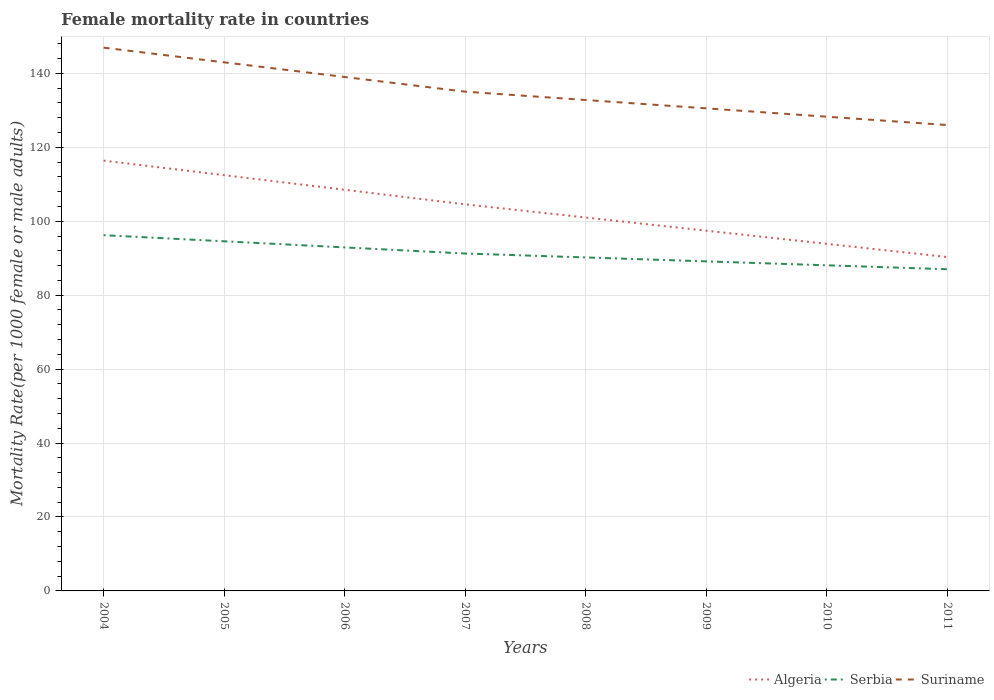Is the number of lines equal to the number of legend labels?
Provide a succinct answer. Yes. Across all years, what is the maximum female mortality rate in Algeria?
Provide a succinct answer. 90.32. In which year was the female mortality rate in Algeria maximum?
Ensure brevity in your answer.  2011. What is the total female mortality rate in Suriname in the graph?
Provide a short and direct response. 12.99. What is the difference between the highest and the second highest female mortality rate in Suriname?
Offer a terse response. 20.93. What is the difference between the highest and the lowest female mortality rate in Suriname?
Your answer should be compact. 3. Is the female mortality rate in Serbia strictly greater than the female mortality rate in Suriname over the years?
Keep it short and to the point. Yes. How many lines are there?
Your answer should be compact. 3. How many years are there in the graph?
Your answer should be compact. 8. What is the difference between two consecutive major ticks on the Y-axis?
Your answer should be compact. 20. Does the graph contain any zero values?
Ensure brevity in your answer.  No. Where does the legend appear in the graph?
Offer a terse response. Bottom right. How many legend labels are there?
Your answer should be very brief. 3. How are the legend labels stacked?
Offer a very short reply. Horizontal. What is the title of the graph?
Ensure brevity in your answer.  Female mortality rate in countries. What is the label or title of the Y-axis?
Your answer should be very brief. Mortality Rate(per 1000 female or male adults). What is the Mortality Rate(per 1000 female or male adults) in Algeria in 2004?
Give a very brief answer. 116.4. What is the Mortality Rate(per 1000 female or male adults) of Serbia in 2004?
Offer a terse response. 96.22. What is the Mortality Rate(per 1000 female or male adults) of Suriname in 2004?
Your response must be concise. 146.95. What is the Mortality Rate(per 1000 female or male adults) in Algeria in 2005?
Give a very brief answer. 112.46. What is the Mortality Rate(per 1000 female or male adults) in Serbia in 2005?
Make the answer very short. 94.57. What is the Mortality Rate(per 1000 female or male adults) of Suriname in 2005?
Your answer should be compact. 142.98. What is the Mortality Rate(per 1000 female or male adults) of Algeria in 2006?
Your response must be concise. 108.51. What is the Mortality Rate(per 1000 female or male adults) in Serbia in 2006?
Your answer should be compact. 92.92. What is the Mortality Rate(per 1000 female or male adults) in Suriname in 2006?
Offer a terse response. 139.02. What is the Mortality Rate(per 1000 female or male adults) of Algeria in 2007?
Your answer should be very brief. 104.57. What is the Mortality Rate(per 1000 female or male adults) in Serbia in 2007?
Your answer should be compact. 91.27. What is the Mortality Rate(per 1000 female or male adults) in Suriname in 2007?
Make the answer very short. 135.05. What is the Mortality Rate(per 1000 female or male adults) in Algeria in 2008?
Your answer should be compact. 101.01. What is the Mortality Rate(per 1000 female or male adults) of Serbia in 2008?
Your response must be concise. 90.21. What is the Mortality Rate(per 1000 female or male adults) of Suriname in 2008?
Make the answer very short. 132.79. What is the Mortality Rate(per 1000 female or male adults) of Algeria in 2009?
Offer a terse response. 97.44. What is the Mortality Rate(per 1000 female or male adults) in Serbia in 2009?
Give a very brief answer. 89.14. What is the Mortality Rate(per 1000 female or male adults) of Suriname in 2009?
Your answer should be very brief. 130.53. What is the Mortality Rate(per 1000 female or male adults) of Algeria in 2010?
Make the answer very short. 93.88. What is the Mortality Rate(per 1000 female or male adults) of Serbia in 2010?
Your answer should be very brief. 88.08. What is the Mortality Rate(per 1000 female or male adults) in Suriname in 2010?
Your response must be concise. 128.28. What is the Mortality Rate(per 1000 female or male adults) in Algeria in 2011?
Give a very brief answer. 90.32. What is the Mortality Rate(per 1000 female or male adults) in Serbia in 2011?
Offer a very short reply. 87.02. What is the Mortality Rate(per 1000 female or male adults) of Suriname in 2011?
Give a very brief answer. 126.02. Across all years, what is the maximum Mortality Rate(per 1000 female or male adults) in Algeria?
Keep it short and to the point. 116.4. Across all years, what is the maximum Mortality Rate(per 1000 female or male adults) of Serbia?
Provide a succinct answer. 96.22. Across all years, what is the maximum Mortality Rate(per 1000 female or male adults) of Suriname?
Give a very brief answer. 146.95. Across all years, what is the minimum Mortality Rate(per 1000 female or male adults) in Algeria?
Your answer should be very brief. 90.32. Across all years, what is the minimum Mortality Rate(per 1000 female or male adults) in Serbia?
Your answer should be very brief. 87.02. Across all years, what is the minimum Mortality Rate(per 1000 female or male adults) in Suriname?
Keep it short and to the point. 126.02. What is the total Mortality Rate(per 1000 female or male adults) in Algeria in the graph?
Make the answer very short. 824.58. What is the total Mortality Rate(per 1000 female or male adults) in Serbia in the graph?
Keep it short and to the point. 729.43. What is the total Mortality Rate(per 1000 female or male adults) in Suriname in the graph?
Your answer should be very brief. 1081.62. What is the difference between the Mortality Rate(per 1000 female or male adults) of Algeria in 2004 and that in 2005?
Your answer should be compact. 3.94. What is the difference between the Mortality Rate(per 1000 female or male adults) of Serbia in 2004 and that in 2005?
Ensure brevity in your answer.  1.65. What is the difference between the Mortality Rate(per 1000 female or male adults) of Suriname in 2004 and that in 2005?
Provide a succinct answer. 3.97. What is the difference between the Mortality Rate(per 1000 female or male adults) of Algeria in 2004 and that in 2006?
Your response must be concise. 7.89. What is the difference between the Mortality Rate(per 1000 female or male adults) in Serbia in 2004 and that in 2006?
Your response must be concise. 3.3. What is the difference between the Mortality Rate(per 1000 female or male adults) of Suriname in 2004 and that in 2006?
Ensure brevity in your answer.  7.94. What is the difference between the Mortality Rate(per 1000 female or male adults) of Algeria in 2004 and that in 2007?
Your answer should be compact. 11.83. What is the difference between the Mortality Rate(per 1000 female or male adults) in Serbia in 2004 and that in 2007?
Your answer should be compact. 4.96. What is the difference between the Mortality Rate(per 1000 female or male adults) of Suriname in 2004 and that in 2007?
Offer a terse response. 11.9. What is the difference between the Mortality Rate(per 1000 female or male adults) of Algeria in 2004 and that in 2008?
Your response must be concise. 15.39. What is the difference between the Mortality Rate(per 1000 female or male adults) in Serbia in 2004 and that in 2008?
Make the answer very short. 6.02. What is the difference between the Mortality Rate(per 1000 female or male adults) of Suriname in 2004 and that in 2008?
Keep it short and to the point. 14.16. What is the difference between the Mortality Rate(per 1000 female or male adults) of Algeria in 2004 and that in 2009?
Provide a succinct answer. 18.96. What is the difference between the Mortality Rate(per 1000 female or male adults) in Serbia in 2004 and that in 2009?
Ensure brevity in your answer.  7.08. What is the difference between the Mortality Rate(per 1000 female or male adults) of Suriname in 2004 and that in 2009?
Keep it short and to the point. 16.42. What is the difference between the Mortality Rate(per 1000 female or male adults) in Algeria in 2004 and that in 2010?
Offer a very short reply. 22.52. What is the difference between the Mortality Rate(per 1000 female or male adults) in Serbia in 2004 and that in 2010?
Your answer should be compact. 8.14. What is the difference between the Mortality Rate(per 1000 female or male adults) of Suriname in 2004 and that in 2010?
Provide a succinct answer. 18.68. What is the difference between the Mortality Rate(per 1000 female or male adults) in Algeria in 2004 and that in 2011?
Your response must be concise. 26.08. What is the difference between the Mortality Rate(per 1000 female or male adults) of Serbia in 2004 and that in 2011?
Ensure brevity in your answer.  9.21. What is the difference between the Mortality Rate(per 1000 female or male adults) in Suriname in 2004 and that in 2011?
Provide a succinct answer. 20.93. What is the difference between the Mortality Rate(per 1000 female or male adults) of Algeria in 2005 and that in 2006?
Ensure brevity in your answer.  3.94. What is the difference between the Mortality Rate(per 1000 female or male adults) in Serbia in 2005 and that in 2006?
Give a very brief answer. 1.65. What is the difference between the Mortality Rate(per 1000 female or male adults) in Suriname in 2005 and that in 2006?
Make the answer very short. 3.97. What is the difference between the Mortality Rate(per 1000 female or male adults) of Algeria in 2005 and that in 2007?
Keep it short and to the point. 7.89. What is the difference between the Mortality Rate(per 1000 female or male adults) of Serbia in 2005 and that in 2007?
Offer a terse response. 3.3. What is the difference between the Mortality Rate(per 1000 female or male adults) of Suriname in 2005 and that in 2007?
Keep it short and to the point. 7.94. What is the difference between the Mortality Rate(per 1000 female or male adults) in Algeria in 2005 and that in 2008?
Give a very brief answer. 11.45. What is the difference between the Mortality Rate(per 1000 female or male adults) in Serbia in 2005 and that in 2008?
Ensure brevity in your answer.  4.37. What is the difference between the Mortality Rate(per 1000 female or male adults) of Suriname in 2005 and that in 2008?
Your answer should be compact. 10.19. What is the difference between the Mortality Rate(per 1000 female or male adults) in Algeria in 2005 and that in 2009?
Keep it short and to the point. 15.01. What is the difference between the Mortality Rate(per 1000 female or male adults) of Serbia in 2005 and that in 2009?
Give a very brief answer. 5.43. What is the difference between the Mortality Rate(per 1000 female or male adults) in Suriname in 2005 and that in 2009?
Your response must be concise. 12.45. What is the difference between the Mortality Rate(per 1000 female or male adults) in Algeria in 2005 and that in 2010?
Your answer should be very brief. 18.58. What is the difference between the Mortality Rate(per 1000 female or male adults) of Serbia in 2005 and that in 2010?
Make the answer very short. 6.49. What is the difference between the Mortality Rate(per 1000 female or male adults) of Suriname in 2005 and that in 2010?
Make the answer very short. 14.71. What is the difference between the Mortality Rate(per 1000 female or male adults) in Algeria in 2005 and that in 2011?
Keep it short and to the point. 22.14. What is the difference between the Mortality Rate(per 1000 female or male adults) of Serbia in 2005 and that in 2011?
Make the answer very short. 7.56. What is the difference between the Mortality Rate(per 1000 female or male adults) of Suriname in 2005 and that in 2011?
Make the answer very short. 16.96. What is the difference between the Mortality Rate(per 1000 female or male adults) of Algeria in 2006 and that in 2007?
Your answer should be very brief. 3.94. What is the difference between the Mortality Rate(per 1000 female or male adults) in Serbia in 2006 and that in 2007?
Give a very brief answer. 1.65. What is the difference between the Mortality Rate(per 1000 female or male adults) in Suriname in 2006 and that in 2007?
Give a very brief answer. 3.97. What is the difference between the Mortality Rate(per 1000 female or male adults) in Algeria in 2006 and that in 2008?
Make the answer very short. 7.51. What is the difference between the Mortality Rate(per 1000 female or male adults) in Serbia in 2006 and that in 2008?
Offer a very short reply. 2.71. What is the difference between the Mortality Rate(per 1000 female or male adults) in Suriname in 2006 and that in 2008?
Provide a succinct answer. 6.22. What is the difference between the Mortality Rate(per 1000 female or male adults) of Algeria in 2006 and that in 2009?
Make the answer very short. 11.07. What is the difference between the Mortality Rate(per 1000 female or male adults) of Serbia in 2006 and that in 2009?
Provide a short and direct response. 3.78. What is the difference between the Mortality Rate(per 1000 female or male adults) in Suriname in 2006 and that in 2009?
Provide a short and direct response. 8.48. What is the difference between the Mortality Rate(per 1000 female or male adults) of Algeria in 2006 and that in 2010?
Offer a terse response. 14.63. What is the difference between the Mortality Rate(per 1000 female or male adults) in Serbia in 2006 and that in 2010?
Offer a very short reply. 4.84. What is the difference between the Mortality Rate(per 1000 female or male adults) of Suriname in 2006 and that in 2010?
Your answer should be compact. 10.74. What is the difference between the Mortality Rate(per 1000 female or male adults) of Algeria in 2006 and that in 2011?
Provide a short and direct response. 18.2. What is the difference between the Mortality Rate(per 1000 female or male adults) of Serbia in 2006 and that in 2011?
Keep it short and to the point. 5.9. What is the difference between the Mortality Rate(per 1000 female or male adults) in Suriname in 2006 and that in 2011?
Your answer should be very brief. 12.99. What is the difference between the Mortality Rate(per 1000 female or male adults) in Algeria in 2007 and that in 2008?
Keep it short and to the point. 3.56. What is the difference between the Mortality Rate(per 1000 female or male adults) of Serbia in 2007 and that in 2008?
Your answer should be compact. 1.06. What is the difference between the Mortality Rate(per 1000 female or male adults) in Suriname in 2007 and that in 2008?
Ensure brevity in your answer.  2.26. What is the difference between the Mortality Rate(per 1000 female or male adults) of Algeria in 2007 and that in 2009?
Keep it short and to the point. 7.13. What is the difference between the Mortality Rate(per 1000 female or male adults) in Serbia in 2007 and that in 2009?
Your answer should be very brief. 2.13. What is the difference between the Mortality Rate(per 1000 female or male adults) of Suriname in 2007 and that in 2009?
Offer a terse response. 4.51. What is the difference between the Mortality Rate(per 1000 female or male adults) in Algeria in 2007 and that in 2010?
Keep it short and to the point. 10.69. What is the difference between the Mortality Rate(per 1000 female or male adults) in Serbia in 2007 and that in 2010?
Make the answer very short. 3.19. What is the difference between the Mortality Rate(per 1000 female or male adults) in Suriname in 2007 and that in 2010?
Make the answer very short. 6.77. What is the difference between the Mortality Rate(per 1000 female or male adults) of Algeria in 2007 and that in 2011?
Ensure brevity in your answer.  14.25. What is the difference between the Mortality Rate(per 1000 female or male adults) in Serbia in 2007 and that in 2011?
Make the answer very short. 4.25. What is the difference between the Mortality Rate(per 1000 female or male adults) in Suriname in 2007 and that in 2011?
Offer a very short reply. 9.03. What is the difference between the Mortality Rate(per 1000 female or male adults) of Algeria in 2008 and that in 2009?
Your answer should be very brief. 3.56. What is the difference between the Mortality Rate(per 1000 female or male adults) in Serbia in 2008 and that in 2009?
Ensure brevity in your answer.  1.06. What is the difference between the Mortality Rate(per 1000 female or male adults) in Suriname in 2008 and that in 2009?
Your response must be concise. 2.26. What is the difference between the Mortality Rate(per 1000 female or male adults) in Algeria in 2008 and that in 2010?
Your answer should be very brief. 7.13. What is the difference between the Mortality Rate(per 1000 female or male adults) of Serbia in 2008 and that in 2010?
Your response must be concise. 2.13. What is the difference between the Mortality Rate(per 1000 female or male adults) in Suriname in 2008 and that in 2010?
Provide a short and direct response. 4.51. What is the difference between the Mortality Rate(per 1000 female or male adults) of Algeria in 2008 and that in 2011?
Provide a short and direct response. 10.69. What is the difference between the Mortality Rate(per 1000 female or male adults) in Serbia in 2008 and that in 2011?
Provide a short and direct response. 3.19. What is the difference between the Mortality Rate(per 1000 female or male adults) of Suriname in 2008 and that in 2011?
Ensure brevity in your answer.  6.77. What is the difference between the Mortality Rate(per 1000 female or male adults) in Algeria in 2009 and that in 2010?
Give a very brief answer. 3.56. What is the difference between the Mortality Rate(per 1000 female or male adults) in Serbia in 2009 and that in 2010?
Your answer should be compact. 1.06. What is the difference between the Mortality Rate(per 1000 female or male adults) of Suriname in 2009 and that in 2010?
Ensure brevity in your answer.  2.26. What is the difference between the Mortality Rate(per 1000 female or male adults) in Algeria in 2009 and that in 2011?
Your answer should be very brief. 7.13. What is the difference between the Mortality Rate(per 1000 female or male adults) in Serbia in 2009 and that in 2011?
Make the answer very short. 2.13. What is the difference between the Mortality Rate(per 1000 female or male adults) in Suriname in 2009 and that in 2011?
Make the answer very short. 4.51. What is the difference between the Mortality Rate(per 1000 female or male adults) in Algeria in 2010 and that in 2011?
Ensure brevity in your answer.  3.56. What is the difference between the Mortality Rate(per 1000 female or male adults) in Serbia in 2010 and that in 2011?
Give a very brief answer. 1.06. What is the difference between the Mortality Rate(per 1000 female or male adults) in Suriname in 2010 and that in 2011?
Make the answer very short. 2.26. What is the difference between the Mortality Rate(per 1000 female or male adults) in Algeria in 2004 and the Mortality Rate(per 1000 female or male adults) in Serbia in 2005?
Your answer should be very brief. 21.83. What is the difference between the Mortality Rate(per 1000 female or male adults) in Algeria in 2004 and the Mortality Rate(per 1000 female or male adults) in Suriname in 2005?
Offer a very short reply. -26.58. What is the difference between the Mortality Rate(per 1000 female or male adults) of Serbia in 2004 and the Mortality Rate(per 1000 female or male adults) of Suriname in 2005?
Your response must be concise. -46.76. What is the difference between the Mortality Rate(per 1000 female or male adults) of Algeria in 2004 and the Mortality Rate(per 1000 female or male adults) of Serbia in 2006?
Provide a succinct answer. 23.48. What is the difference between the Mortality Rate(per 1000 female or male adults) in Algeria in 2004 and the Mortality Rate(per 1000 female or male adults) in Suriname in 2006?
Your response must be concise. -22.62. What is the difference between the Mortality Rate(per 1000 female or male adults) of Serbia in 2004 and the Mortality Rate(per 1000 female or male adults) of Suriname in 2006?
Give a very brief answer. -42.79. What is the difference between the Mortality Rate(per 1000 female or male adults) in Algeria in 2004 and the Mortality Rate(per 1000 female or male adults) in Serbia in 2007?
Your response must be concise. 25.13. What is the difference between the Mortality Rate(per 1000 female or male adults) of Algeria in 2004 and the Mortality Rate(per 1000 female or male adults) of Suriname in 2007?
Offer a terse response. -18.65. What is the difference between the Mortality Rate(per 1000 female or male adults) of Serbia in 2004 and the Mortality Rate(per 1000 female or male adults) of Suriname in 2007?
Your response must be concise. -38.82. What is the difference between the Mortality Rate(per 1000 female or male adults) of Algeria in 2004 and the Mortality Rate(per 1000 female or male adults) of Serbia in 2008?
Provide a succinct answer. 26.19. What is the difference between the Mortality Rate(per 1000 female or male adults) of Algeria in 2004 and the Mortality Rate(per 1000 female or male adults) of Suriname in 2008?
Your response must be concise. -16.39. What is the difference between the Mortality Rate(per 1000 female or male adults) of Serbia in 2004 and the Mortality Rate(per 1000 female or male adults) of Suriname in 2008?
Keep it short and to the point. -36.57. What is the difference between the Mortality Rate(per 1000 female or male adults) of Algeria in 2004 and the Mortality Rate(per 1000 female or male adults) of Serbia in 2009?
Give a very brief answer. 27.26. What is the difference between the Mortality Rate(per 1000 female or male adults) in Algeria in 2004 and the Mortality Rate(per 1000 female or male adults) in Suriname in 2009?
Offer a very short reply. -14.13. What is the difference between the Mortality Rate(per 1000 female or male adults) of Serbia in 2004 and the Mortality Rate(per 1000 female or male adults) of Suriname in 2009?
Offer a terse response. -34.31. What is the difference between the Mortality Rate(per 1000 female or male adults) in Algeria in 2004 and the Mortality Rate(per 1000 female or male adults) in Serbia in 2010?
Provide a succinct answer. 28.32. What is the difference between the Mortality Rate(per 1000 female or male adults) in Algeria in 2004 and the Mortality Rate(per 1000 female or male adults) in Suriname in 2010?
Your answer should be very brief. -11.88. What is the difference between the Mortality Rate(per 1000 female or male adults) in Serbia in 2004 and the Mortality Rate(per 1000 female or male adults) in Suriname in 2010?
Ensure brevity in your answer.  -32.05. What is the difference between the Mortality Rate(per 1000 female or male adults) of Algeria in 2004 and the Mortality Rate(per 1000 female or male adults) of Serbia in 2011?
Give a very brief answer. 29.38. What is the difference between the Mortality Rate(per 1000 female or male adults) in Algeria in 2004 and the Mortality Rate(per 1000 female or male adults) in Suriname in 2011?
Provide a short and direct response. -9.62. What is the difference between the Mortality Rate(per 1000 female or male adults) in Serbia in 2004 and the Mortality Rate(per 1000 female or male adults) in Suriname in 2011?
Ensure brevity in your answer.  -29.8. What is the difference between the Mortality Rate(per 1000 female or male adults) in Algeria in 2005 and the Mortality Rate(per 1000 female or male adults) in Serbia in 2006?
Provide a short and direct response. 19.54. What is the difference between the Mortality Rate(per 1000 female or male adults) of Algeria in 2005 and the Mortality Rate(per 1000 female or male adults) of Suriname in 2006?
Keep it short and to the point. -26.56. What is the difference between the Mortality Rate(per 1000 female or male adults) in Serbia in 2005 and the Mortality Rate(per 1000 female or male adults) in Suriname in 2006?
Offer a terse response. -44.44. What is the difference between the Mortality Rate(per 1000 female or male adults) in Algeria in 2005 and the Mortality Rate(per 1000 female or male adults) in Serbia in 2007?
Provide a short and direct response. 21.19. What is the difference between the Mortality Rate(per 1000 female or male adults) of Algeria in 2005 and the Mortality Rate(per 1000 female or male adults) of Suriname in 2007?
Your response must be concise. -22.59. What is the difference between the Mortality Rate(per 1000 female or male adults) in Serbia in 2005 and the Mortality Rate(per 1000 female or male adults) in Suriname in 2007?
Give a very brief answer. -40.48. What is the difference between the Mortality Rate(per 1000 female or male adults) of Algeria in 2005 and the Mortality Rate(per 1000 female or male adults) of Serbia in 2008?
Provide a short and direct response. 22.25. What is the difference between the Mortality Rate(per 1000 female or male adults) in Algeria in 2005 and the Mortality Rate(per 1000 female or male adults) in Suriname in 2008?
Offer a terse response. -20.33. What is the difference between the Mortality Rate(per 1000 female or male adults) in Serbia in 2005 and the Mortality Rate(per 1000 female or male adults) in Suriname in 2008?
Keep it short and to the point. -38.22. What is the difference between the Mortality Rate(per 1000 female or male adults) of Algeria in 2005 and the Mortality Rate(per 1000 female or male adults) of Serbia in 2009?
Your response must be concise. 23.31. What is the difference between the Mortality Rate(per 1000 female or male adults) of Algeria in 2005 and the Mortality Rate(per 1000 female or male adults) of Suriname in 2009?
Provide a succinct answer. -18.08. What is the difference between the Mortality Rate(per 1000 female or male adults) of Serbia in 2005 and the Mortality Rate(per 1000 female or male adults) of Suriname in 2009?
Offer a very short reply. -35.96. What is the difference between the Mortality Rate(per 1000 female or male adults) in Algeria in 2005 and the Mortality Rate(per 1000 female or male adults) in Serbia in 2010?
Ensure brevity in your answer.  24.38. What is the difference between the Mortality Rate(per 1000 female or male adults) in Algeria in 2005 and the Mortality Rate(per 1000 female or male adults) in Suriname in 2010?
Your response must be concise. -15.82. What is the difference between the Mortality Rate(per 1000 female or male adults) in Serbia in 2005 and the Mortality Rate(per 1000 female or male adults) in Suriname in 2010?
Offer a terse response. -33.71. What is the difference between the Mortality Rate(per 1000 female or male adults) of Algeria in 2005 and the Mortality Rate(per 1000 female or male adults) of Serbia in 2011?
Give a very brief answer. 25.44. What is the difference between the Mortality Rate(per 1000 female or male adults) of Algeria in 2005 and the Mortality Rate(per 1000 female or male adults) of Suriname in 2011?
Make the answer very short. -13.56. What is the difference between the Mortality Rate(per 1000 female or male adults) of Serbia in 2005 and the Mortality Rate(per 1000 female or male adults) of Suriname in 2011?
Provide a succinct answer. -31.45. What is the difference between the Mortality Rate(per 1000 female or male adults) in Algeria in 2006 and the Mortality Rate(per 1000 female or male adults) in Serbia in 2007?
Offer a terse response. 17.24. What is the difference between the Mortality Rate(per 1000 female or male adults) of Algeria in 2006 and the Mortality Rate(per 1000 female or male adults) of Suriname in 2007?
Provide a short and direct response. -26.54. What is the difference between the Mortality Rate(per 1000 female or male adults) in Serbia in 2006 and the Mortality Rate(per 1000 female or male adults) in Suriname in 2007?
Provide a succinct answer. -42.13. What is the difference between the Mortality Rate(per 1000 female or male adults) in Algeria in 2006 and the Mortality Rate(per 1000 female or male adults) in Serbia in 2008?
Ensure brevity in your answer.  18.31. What is the difference between the Mortality Rate(per 1000 female or male adults) of Algeria in 2006 and the Mortality Rate(per 1000 female or male adults) of Suriname in 2008?
Your answer should be compact. -24.28. What is the difference between the Mortality Rate(per 1000 female or male adults) in Serbia in 2006 and the Mortality Rate(per 1000 female or male adults) in Suriname in 2008?
Provide a succinct answer. -39.87. What is the difference between the Mortality Rate(per 1000 female or male adults) of Algeria in 2006 and the Mortality Rate(per 1000 female or male adults) of Serbia in 2009?
Provide a short and direct response. 19.37. What is the difference between the Mortality Rate(per 1000 female or male adults) of Algeria in 2006 and the Mortality Rate(per 1000 female or male adults) of Suriname in 2009?
Offer a very short reply. -22.02. What is the difference between the Mortality Rate(per 1000 female or male adults) in Serbia in 2006 and the Mortality Rate(per 1000 female or male adults) in Suriname in 2009?
Provide a short and direct response. -37.61. What is the difference between the Mortality Rate(per 1000 female or male adults) in Algeria in 2006 and the Mortality Rate(per 1000 female or male adults) in Serbia in 2010?
Provide a succinct answer. 20.43. What is the difference between the Mortality Rate(per 1000 female or male adults) of Algeria in 2006 and the Mortality Rate(per 1000 female or male adults) of Suriname in 2010?
Your response must be concise. -19.77. What is the difference between the Mortality Rate(per 1000 female or male adults) of Serbia in 2006 and the Mortality Rate(per 1000 female or male adults) of Suriname in 2010?
Your answer should be very brief. -35.36. What is the difference between the Mortality Rate(per 1000 female or male adults) of Algeria in 2006 and the Mortality Rate(per 1000 female or male adults) of Serbia in 2011?
Give a very brief answer. 21.5. What is the difference between the Mortality Rate(per 1000 female or male adults) in Algeria in 2006 and the Mortality Rate(per 1000 female or male adults) in Suriname in 2011?
Keep it short and to the point. -17.51. What is the difference between the Mortality Rate(per 1000 female or male adults) of Serbia in 2006 and the Mortality Rate(per 1000 female or male adults) of Suriname in 2011?
Make the answer very short. -33.1. What is the difference between the Mortality Rate(per 1000 female or male adults) of Algeria in 2007 and the Mortality Rate(per 1000 female or male adults) of Serbia in 2008?
Your answer should be compact. 14.36. What is the difference between the Mortality Rate(per 1000 female or male adults) of Algeria in 2007 and the Mortality Rate(per 1000 female or male adults) of Suriname in 2008?
Make the answer very short. -28.22. What is the difference between the Mortality Rate(per 1000 female or male adults) in Serbia in 2007 and the Mortality Rate(per 1000 female or male adults) in Suriname in 2008?
Provide a succinct answer. -41.52. What is the difference between the Mortality Rate(per 1000 female or male adults) of Algeria in 2007 and the Mortality Rate(per 1000 female or male adults) of Serbia in 2009?
Offer a terse response. 15.43. What is the difference between the Mortality Rate(per 1000 female or male adults) of Algeria in 2007 and the Mortality Rate(per 1000 female or male adults) of Suriname in 2009?
Your answer should be very brief. -25.96. What is the difference between the Mortality Rate(per 1000 female or male adults) in Serbia in 2007 and the Mortality Rate(per 1000 female or male adults) in Suriname in 2009?
Give a very brief answer. -39.27. What is the difference between the Mortality Rate(per 1000 female or male adults) in Algeria in 2007 and the Mortality Rate(per 1000 female or male adults) in Serbia in 2010?
Give a very brief answer. 16.49. What is the difference between the Mortality Rate(per 1000 female or male adults) in Algeria in 2007 and the Mortality Rate(per 1000 female or male adults) in Suriname in 2010?
Keep it short and to the point. -23.71. What is the difference between the Mortality Rate(per 1000 female or male adults) in Serbia in 2007 and the Mortality Rate(per 1000 female or male adults) in Suriname in 2010?
Ensure brevity in your answer.  -37.01. What is the difference between the Mortality Rate(per 1000 female or male adults) in Algeria in 2007 and the Mortality Rate(per 1000 female or male adults) in Serbia in 2011?
Offer a very short reply. 17.55. What is the difference between the Mortality Rate(per 1000 female or male adults) in Algeria in 2007 and the Mortality Rate(per 1000 female or male adults) in Suriname in 2011?
Provide a short and direct response. -21.45. What is the difference between the Mortality Rate(per 1000 female or male adults) in Serbia in 2007 and the Mortality Rate(per 1000 female or male adults) in Suriname in 2011?
Make the answer very short. -34.75. What is the difference between the Mortality Rate(per 1000 female or male adults) in Algeria in 2008 and the Mortality Rate(per 1000 female or male adults) in Serbia in 2009?
Keep it short and to the point. 11.86. What is the difference between the Mortality Rate(per 1000 female or male adults) in Algeria in 2008 and the Mortality Rate(per 1000 female or male adults) in Suriname in 2009?
Your answer should be very brief. -29.53. What is the difference between the Mortality Rate(per 1000 female or male adults) of Serbia in 2008 and the Mortality Rate(per 1000 female or male adults) of Suriname in 2009?
Offer a very short reply. -40.33. What is the difference between the Mortality Rate(per 1000 female or male adults) in Algeria in 2008 and the Mortality Rate(per 1000 female or male adults) in Serbia in 2010?
Make the answer very short. 12.93. What is the difference between the Mortality Rate(per 1000 female or male adults) of Algeria in 2008 and the Mortality Rate(per 1000 female or male adults) of Suriname in 2010?
Your answer should be very brief. -27.27. What is the difference between the Mortality Rate(per 1000 female or male adults) in Serbia in 2008 and the Mortality Rate(per 1000 female or male adults) in Suriname in 2010?
Your response must be concise. -38.07. What is the difference between the Mortality Rate(per 1000 female or male adults) in Algeria in 2008 and the Mortality Rate(per 1000 female or male adults) in Serbia in 2011?
Your answer should be compact. 13.99. What is the difference between the Mortality Rate(per 1000 female or male adults) in Algeria in 2008 and the Mortality Rate(per 1000 female or male adults) in Suriname in 2011?
Give a very brief answer. -25.02. What is the difference between the Mortality Rate(per 1000 female or male adults) of Serbia in 2008 and the Mortality Rate(per 1000 female or male adults) of Suriname in 2011?
Your answer should be very brief. -35.82. What is the difference between the Mortality Rate(per 1000 female or male adults) of Algeria in 2009 and the Mortality Rate(per 1000 female or male adults) of Serbia in 2010?
Ensure brevity in your answer.  9.36. What is the difference between the Mortality Rate(per 1000 female or male adults) in Algeria in 2009 and the Mortality Rate(per 1000 female or male adults) in Suriname in 2010?
Provide a succinct answer. -30.84. What is the difference between the Mortality Rate(per 1000 female or male adults) in Serbia in 2009 and the Mortality Rate(per 1000 female or male adults) in Suriname in 2010?
Your answer should be very brief. -39.14. What is the difference between the Mortality Rate(per 1000 female or male adults) in Algeria in 2009 and the Mortality Rate(per 1000 female or male adults) in Serbia in 2011?
Give a very brief answer. 10.43. What is the difference between the Mortality Rate(per 1000 female or male adults) in Algeria in 2009 and the Mortality Rate(per 1000 female or male adults) in Suriname in 2011?
Offer a very short reply. -28.58. What is the difference between the Mortality Rate(per 1000 female or male adults) of Serbia in 2009 and the Mortality Rate(per 1000 female or male adults) of Suriname in 2011?
Keep it short and to the point. -36.88. What is the difference between the Mortality Rate(per 1000 female or male adults) in Algeria in 2010 and the Mortality Rate(per 1000 female or male adults) in Serbia in 2011?
Your response must be concise. 6.86. What is the difference between the Mortality Rate(per 1000 female or male adults) in Algeria in 2010 and the Mortality Rate(per 1000 female or male adults) in Suriname in 2011?
Make the answer very short. -32.14. What is the difference between the Mortality Rate(per 1000 female or male adults) in Serbia in 2010 and the Mortality Rate(per 1000 female or male adults) in Suriname in 2011?
Provide a succinct answer. -37.94. What is the average Mortality Rate(per 1000 female or male adults) in Algeria per year?
Offer a very short reply. 103.07. What is the average Mortality Rate(per 1000 female or male adults) of Serbia per year?
Make the answer very short. 91.18. What is the average Mortality Rate(per 1000 female or male adults) of Suriname per year?
Keep it short and to the point. 135.2. In the year 2004, what is the difference between the Mortality Rate(per 1000 female or male adults) of Algeria and Mortality Rate(per 1000 female or male adults) of Serbia?
Offer a very short reply. 20.18. In the year 2004, what is the difference between the Mortality Rate(per 1000 female or male adults) in Algeria and Mortality Rate(per 1000 female or male adults) in Suriname?
Your response must be concise. -30.55. In the year 2004, what is the difference between the Mortality Rate(per 1000 female or male adults) in Serbia and Mortality Rate(per 1000 female or male adults) in Suriname?
Offer a terse response. -50.73. In the year 2005, what is the difference between the Mortality Rate(per 1000 female or male adults) of Algeria and Mortality Rate(per 1000 female or male adults) of Serbia?
Provide a short and direct response. 17.88. In the year 2005, what is the difference between the Mortality Rate(per 1000 female or male adults) of Algeria and Mortality Rate(per 1000 female or male adults) of Suriname?
Make the answer very short. -30.53. In the year 2005, what is the difference between the Mortality Rate(per 1000 female or male adults) of Serbia and Mortality Rate(per 1000 female or male adults) of Suriname?
Offer a terse response. -48.41. In the year 2006, what is the difference between the Mortality Rate(per 1000 female or male adults) in Algeria and Mortality Rate(per 1000 female or male adults) in Serbia?
Make the answer very short. 15.59. In the year 2006, what is the difference between the Mortality Rate(per 1000 female or male adults) of Algeria and Mortality Rate(per 1000 female or male adults) of Suriname?
Your response must be concise. -30.5. In the year 2006, what is the difference between the Mortality Rate(per 1000 female or male adults) in Serbia and Mortality Rate(per 1000 female or male adults) in Suriname?
Make the answer very short. -46.1. In the year 2007, what is the difference between the Mortality Rate(per 1000 female or male adults) in Algeria and Mortality Rate(per 1000 female or male adults) in Serbia?
Your answer should be very brief. 13.3. In the year 2007, what is the difference between the Mortality Rate(per 1000 female or male adults) in Algeria and Mortality Rate(per 1000 female or male adults) in Suriname?
Keep it short and to the point. -30.48. In the year 2007, what is the difference between the Mortality Rate(per 1000 female or male adults) in Serbia and Mortality Rate(per 1000 female or male adults) in Suriname?
Keep it short and to the point. -43.78. In the year 2008, what is the difference between the Mortality Rate(per 1000 female or male adults) in Algeria and Mortality Rate(per 1000 female or male adults) in Serbia?
Provide a succinct answer. 10.8. In the year 2008, what is the difference between the Mortality Rate(per 1000 female or male adults) of Algeria and Mortality Rate(per 1000 female or male adults) of Suriname?
Offer a very short reply. -31.79. In the year 2008, what is the difference between the Mortality Rate(per 1000 female or male adults) in Serbia and Mortality Rate(per 1000 female or male adults) in Suriname?
Make the answer very short. -42.59. In the year 2009, what is the difference between the Mortality Rate(per 1000 female or male adults) of Algeria and Mortality Rate(per 1000 female or male adults) of Serbia?
Keep it short and to the point. 8.3. In the year 2009, what is the difference between the Mortality Rate(per 1000 female or male adults) in Algeria and Mortality Rate(per 1000 female or male adults) in Suriname?
Your answer should be compact. -33.09. In the year 2009, what is the difference between the Mortality Rate(per 1000 female or male adults) of Serbia and Mortality Rate(per 1000 female or male adults) of Suriname?
Your answer should be compact. -41.39. In the year 2010, what is the difference between the Mortality Rate(per 1000 female or male adults) in Algeria and Mortality Rate(per 1000 female or male adults) in Serbia?
Keep it short and to the point. 5.8. In the year 2010, what is the difference between the Mortality Rate(per 1000 female or male adults) of Algeria and Mortality Rate(per 1000 female or male adults) of Suriname?
Give a very brief answer. -34.4. In the year 2010, what is the difference between the Mortality Rate(per 1000 female or male adults) of Serbia and Mortality Rate(per 1000 female or male adults) of Suriname?
Keep it short and to the point. -40.2. In the year 2011, what is the difference between the Mortality Rate(per 1000 female or male adults) of Algeria and Mortality Rate(per 1000 female or male adults) of Serbia?
Provide a short and direct response. 3.3. In the year 2011, what is the difference between the Mortality Rate(per 1000 female or male adults) in Algeria and Mortality Rate(per 1000 female or male adults) in Suriname?
Your answer should be very brief. -35.7. In the year 2011, what is the difference between the Mortality Rate(per 1000 female or male adults) of Serbia and Mortality Rate(per 1000 female or male adults) of Suriname?
Give a very brief answer. -39. What is the ratio of the Mortality Rate(per 1000 female or male adults) in Algeria in 2004 to that in 2005?
Keep it short and to the point. 1.04. What is the ratio of the Mortality Rate(per 1000 female or male adults) of Serbia in 2004 to that in 2005?
Your answer should be compact. 1.02. What is the ratio of the Mortality Rate(per 1000 female or male adults) in Suriname in 2004 to that in 2005?
Offer a very short reply. 1.03. What is the ratio of the Mortality Rate(per 1000 female or male adults) in Algeria in 2004 to that in 2006?
Your answer should be compact. 1.07. What is the ratio of the Mortality Rate(per 1000 female or male adults) in Serbia in 2004 to that in 2006?
Your answer should be very brief. 1.04. What is the ratio of the Mortality Rate(per 1000 female or male adults) in Suriname in 2004 to that in 2006?
Ensure brevity in your answer.  1.06. What is the ratio of the Mortality Rate(per 1000 female or male adults) of Algeria in 2004 to that in 2007?
Offer a terse response. 1.11. What is the ratio of the Mortality Rate(per 1000 female or male adults) of Serbia in 2004 to that in 2007?
Give a very brief answer. 1.05. What is the ratio of the Mortality Rate(per 1000 female or male adults) of Suriname in 2004 to that in 2007?
Make the answer very short. 1.09. What is the ratio of the Mortality Rate(per 1000 female or male adults) in Algeria in 2004 to that in 2008?
Your answer should be compact. 1.15. What is the ratio of the Mortality Rate(per 1000 female or male adults) of Serbia in 2004 to that in 2008?
Your answer should be compact. 1.07. What is the ratio of the Mortality Rate(per 1000 female or male adults) in Suriname in 2004 to that in 2008?
Provide a succinct answer. 1.11. What is the ratio of the Mortality Rate(per 1000 female or male adults) of Algeria in 2004 to that in 2009?
Offer a very short reply. 1.19. What is the ratio of the Mortality Rate(per 1000 female or male adults) of Serbia in 2004 to that in 2009?
Your answer should be compact. 1.08. What is the ratio of the Mortality Rate(per 1000 female or male adults) in Suriname in 2004 to that in 2009?
Provide a short and direct response. 1.13. What is the ratio of the Mortality Rate(per 1000 female or male adults) of Algeria in 2004 to that in 2010?
Offer a terse response. 1.24. What is the ratio of the Mortality Rate(per 1000 female or male adults) in Serbia in 2004 to that in 2010?
Make the answer very short. 1.09. What is the ratio of the Mortality Rate(per 1000 female or male adults) of Suriname in 2004 to that in 2010?
Ensure brevity in your answer.  1.15. What is the ratio of the Mortality Rate(per 1000 female or male adults) in Algeria in 2004 to that in 2011?
Ensure brevity in your answer.  1.29. What is the ratio of the Mortality Rate(per 1000 female or male adults) in Serbia in 2004 to that in 2011?
Give a very brief answer. 1.11. What is the ratio of the Mortality Rate(per 1000 female or male adults) of Suriname in 2004 to that in 2011?
Keep it short and to the point. 1.17. What is the ratio of the Mortality Rate(per 1000 female or male adults) in Algeria in 2005 to that in 2006?
Your answer should be compact. 1.04. What is the ratio of the Mortality Rate(per 1000 female or male adults) in Serbia in 2005 to that in 2006?
Offer a terse response. 1.02. What is the ratio of the Mortality Rate(per 1000 female or male adults) of Suriname in 2005 to that in 2006?
Ensure brevity in your answer.  1.03. What is the ratio of the Mortality Rate(per 1000 female or male adults) of Algeria in 2005 to that in 2007?
Offer a terse response. 1.08. What is the ratio of the Mortality Rate(per 1000 female or male adults) in Serbia in 2005 to that in 2007?
Offer a very short reply. 1.04. What is the ratio of the Mortality Rate(per 1000 female or male adults) in Suriname in 2005 to that in 2007?
Your response must be concise. 1.06. What is the ratio of the Mortality Rate(per 1000 female or male adults) in Algeria in 2005 to that in 2008?
Provide a short and direct response. 1.11. What is the ratio of the Mortality Rate(per 1000 female or male adults) of Serbia in 2005 to that in 2008?
Your answer should be very brief. 1.05. What is the ratio of the Mortality Rate(per 1000 female or male adults) in Suriname in 2005 to that in 2008?
Keep it short and to the point. 1.08. What is the ratio of the Mortality Rate(per 1000 female or male adults) in Algeria in 2005 to that in 2009?
Make the answer very short. 1.15. What is the ratio of the Mortality Rate(per 1000 female or male adults) in Serbia in 2005 to that in 2009?
Your answer should be very brief. 1.06. What is the ratio of the Mortality Rate(per 1000 female or male adults) of Suriname in 2005 to that in 2009?
Your response must be concise. 1.1. What is the ratio of the Mortality Rate(per 1000 female or male adults) of Algeria in 2005 to that in 2010?
Offer a very short reply. 1.2. What is the ratio of the Mortality Rate(per 1000 female or male adults) of Serbia in 2005 to that in 2010?
Give a very brief answer. 1.07. What is the ratio of the Mortality Rate(per 1000 female or male adults) of Suriname in 2005 to that in 2010?
Make the answer very short. 1.11. What is the ratio of the Mortality Rate(per 1000 female or male adults) of Algeria in 2005 to that in 2011?
Make the answer very short. 1.25. What is the ratio of the Mortality Rate(per 1000 female or male adults) in Serbia in 2005 to that in 2011?
Your response must be concise. 1.09. What is the ratio of the Mortality Rate(per 1000 female or male adults) of Suriname in 2005 to that in 2011?
Offer a very short reply. 1.13. What is the ratio of the Mortality Rate(per 1000 female or male adults) in Algeria in 2006 to that in 2007?
Offer a terse response. 1.04. What is the ratio of the Mortality Rate(per 1000 female or male adults) of Serbia in 2006 to that in 2007?
Make the answer very short. 1.02. What is the ratio of the Mortality Rate(per 1000 female or male adults) in Suriname in 2006 to that in 2007?
Give a very brief answer. 1.03. What is the ratio of the Mortality Rate(per 1000 female or male adults) of Algeria in 2006 to that in 2008?
Your response must be concise. 1.07. What is the ratio of the Mortality Rate(per 1000 female or male adults) of Serbia in 2006 to that in 2008?
Your response must be concise. 1.03. What is the ratio of the Mortality Rate(per 1000 female or male adults) of Suriname in 2006 to that in 2008?
Your answer should be very brief. 1.05. What is the ratio of the Mortality Rate(per 1000 female or male adults) in Algeria in 2006 to that in 2009?
Offer a terse response. 1.11. What is the ratio of the Mortality Rate(per 1000 female or male adults) of Serbia in 2006 to that in 2009?
Ensure brevity in your answer.  1.04. What is the ratio of the Mortality Rate(per 1000 female or male adults) of Suriname in 2006 to that in 2009?
Give a very brief answer. 1.06. What is the ratio of the Mortality Rate(per 1000 female or male adults) of Algeria in 2006 to that in 2010?
Ensure brevity in your answer.  1.16. What is the ratio of the Mortality Rate(per 1000 female or male adults) in Serbia in 2006 to that in 2010?
Make the answer very short. 1.05. What is the ratio of the Mortality Rate(per 1000 female or male adults) in Suriname in 2006 to that in 2010?
Your response must be concise. 1.08. What is the ratio of the Mortality Rate(per 1000 female or male adults) of Algeria in 2006 to that in 2011?
Offer a terse response. 1.2. What is the ratio of the Mortality Rate(per 1000 female or male adults) in Serbia in 2006 to that in 2011?
Offer a very short reply. 1.07. What is the ratio of the Mortality Rate(per 1000 female or male adults) of Suriname in 2006 to that in 2011?
Offer a very short reply. 1.1. What is the ratio of the Mortality Rate(per 1000 female or male adults) of Algeria in 2007 to that in 2008?
Give a very brief answer. 1.04. What is the ratio of the Mortality Rate(per 1000 female or male adults) in Serbia in 2007 to that in 2008?
Your answer should be compact. 1.01. What is the ratio of the Mortality Rate(per 1000 female or male adults) of Algeria in 2007 to that in 2009?
Provide a succinct answer. 1.07. What is the ratio of the Mortality Rate(per 1000 female or male adults) in Serbia in 2007 to that in 2009?
Your answer should be very brief. 1.02. What is the ratio of the Mortality Rate(per 1000 female or male adults) of Suriname in 2007 to that in 2009?
Your answer should be compact. 1.03. What is the ratio of the Mortality Rate(per 1000 female or male adults) in Algeria in 2007 to that in 2010?
Provide a succinct answer. 1.11. What is the ratio of the Mortality Rate(per 1000 female or male adults) of Serbia in 2007 to that in 2010?
Ensure brevity in your answer.  1.04. What is the ratio of the Mortality Rate(per 1000 female or male adults) in Suriname in 2007 to that in 2010?
Keep it short and to the point. 1.05. What is the ratio of the Mortality Rate(per 1000 female or male adults) in Algeria in 2007 to that in 2011?
Provide a succinct answer. 1.16. What is the ratio of the Mortality Rate(per 1000 female or male adults) in Serbia in 2007 to that in 2011?
Provide a succinct answer. 1.05. What is the ratio of the Mortality Rate(per 1000 female or male adults) in Suriname in 2007 to that in 2011?
Provide a short and direct response. 1.07. What is the ratio of the Mortality Rate(per 1000 female or male adults) of Algeria in 2008 to that in 2009?
Offer a very short reply. 1.04. What is the ratio of the Mortality Rate(per 1000 female or male adults) of Serbia in 2008 to that in 2009?
Offer a very short reply. 1.01. What is the ratio of the Mortality Rate(per 1000 female or male adults) of Suriname in 2008 to that in 2009?
Give a very brief answer. 1.02. What is the ratio of the Mortality Rate(per 1000 female or male adults) of Algeria in 2008 to that in 2010?
Your answer should be very brief. 1.08. What is the ratio of the Mortality Rate(per 1000 female or male adults) in Serbia in 2008 to that in 2010?
Keep it short and to the point. 1.02. What is the ratio of the Mortality Rate(per 1000 female or male adults) of Suriname in 2008 to that in 2010?
Keep it short and to the point. 1.04. What is the ratio of the Mortality Rate(per 1000 female or male adults) in Algeria in 2008 to that in 2011?
Your answer should be compact. 1.12. What is the ratio of the Mortality Rate(per 1000 female or male adults) of Serbia in 2008 to that in 2011?
Your response must be concise. 1.04. What is the ratio of the Mortality Rate(per 1000 female or male adults) of Suriname in 2008 to that in 2011?
Make the answer very short. 1.05. What is the ratio of the Mortality Rate(per 1000 female or male adults) in Algeria in 2009 to that in 2010?
Provide a short and direct response. 1.04. What is the ratio of the Mortality Rate(per 1000 female or male adults) in Serbia in 2009 to that in 2010?
Offer a very short reply. 1.01. What is the ratio of the Mortality Rate(per 1000 female or male adults) of Suriname in 2009 to that in 2010?
Give a very brief answer. 1.02. What is the ratio of the Mortality Rate(per 1000 female or male adults) of Algeria in 2009 to that in 2011?
Offer a terse response. 1.08. What is the ratio of the Mortality Rate(per 1000 female or male adults) in Serbia in 2009 to that in 2011?
Give a very brief answer. 1.02. What is the ratio of the Mortality Rate(per 1000 female or male adults) in Suriname in 2009 to that in 2011?
Your answer should be compact. 1.04. What is the ratio of the Mortality Rate(per 1000 female or male adults) of Algeria in 2010 to that in 2011?
Your answer should be compact. 1.04. What is the ratio of the Mortality Rate(per 1000 female or male adults) in Serbia in 2010 to that in 2011?
Provide a short and direct response. 1.01. What is the ratio of the Mortality Rate(per 1000 female or male adults) in Suriname in 2010 to that in 2011?
Offer a very short reply. 1.02. What is the difference between the highest and the second highest Mortality Rate(per 1000 female or male adults) in Algeria?
Your response must be concise. 3.94. What is the difference between the highest and the second highest Mortality Rate(per 1000 female or male adults) of Serbia?
Keep it short and to the point. 1.65. What is the difference between the highest and the second highest Mortality Rate(per 1000 female or male adults) in Suriname?
Provide a succinct answer. 3.97. What is the difference between the highest and the lowest Mortality Rate(per 1000 female or male adults) of Algeria?
Keep it short and to the point. 26.08. What is the difference between the highest and the lowest Mortality Rate(per 1000 female or male adults) of Serbia?
Your answer should be very brief. 9.21. What is the difference between the highest and the lowest Mortality Rate(per 1000 female or male adults) of Suriname?
Your response must be concise. 20.93. 